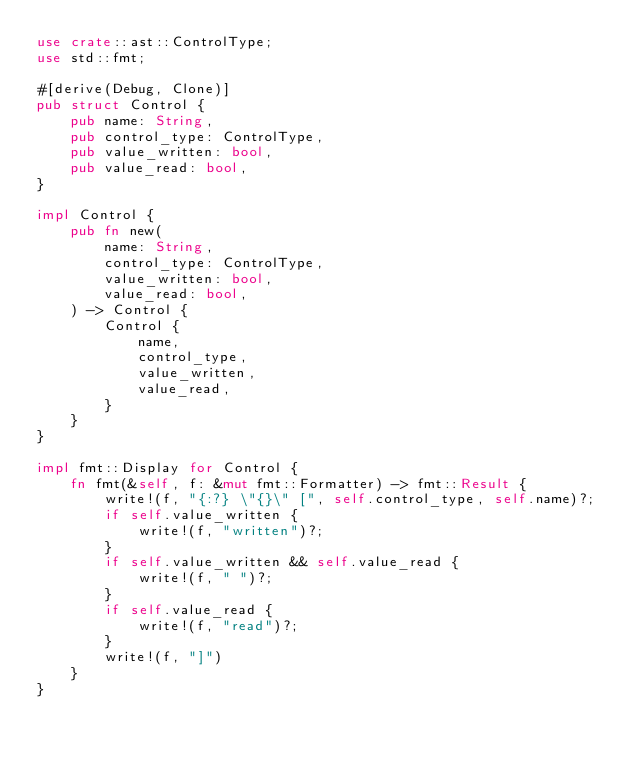<code> <loc_0><loc_0><loc_500><loc_500><_Rust_>use crate::ast::ControlType;
use std::fmt;

#[derive(Debug, Clone)]
pub struct Control {
    pub name: String,
    pub control_type: ControlType,
    pub value_written: bool,
    pub value_read: bool,
}

impl Control {
    pub fn new(
        name: String,
        control_type: ControlType,
        value_written: bool,
        value_read: bool,
    ) -> Control {
        Control {
            name,
            control_type,
            value_written,
            value_read,
        }
    }
}

impl fmt::Display for Control {
    fn fmt(&self, f: &mut fmt::Formatter) -> fmt::Result {
        write!(f, "{:?} \"{}\" [", self.control_type, self.name)?;
        if self.value_written {
            write!(f, "written")?;
        }
        if self.value_written && self.value_read {
            write!(f, " ")?;
        }
        if self.value_read {
            write!(f, "read")?;
        }
        write!(f, "]")
    }
}
</code> 